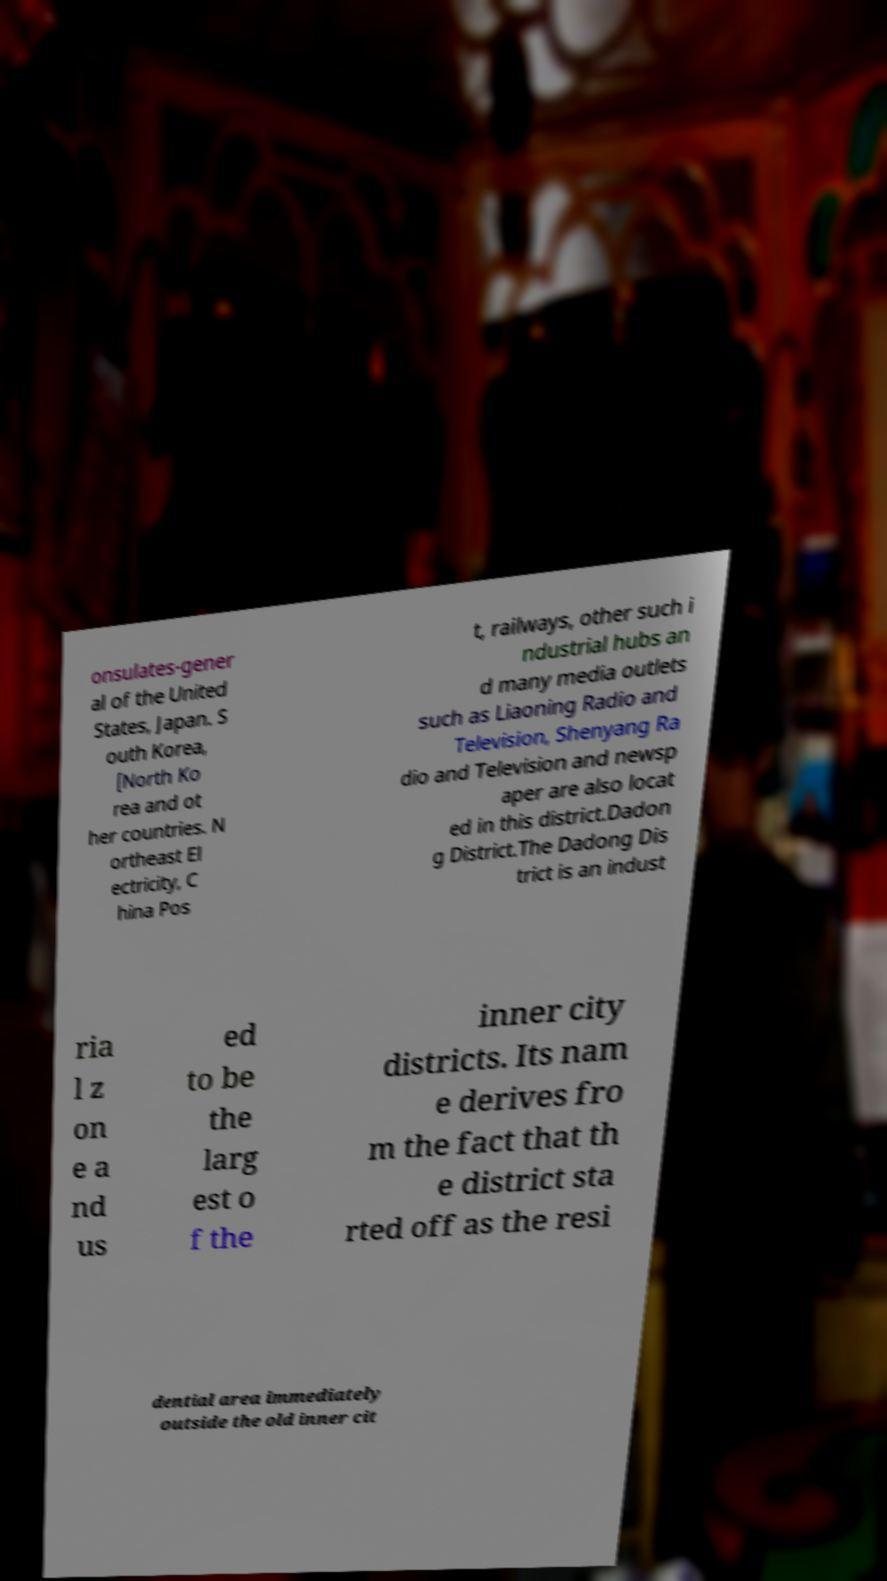Can you read and provide the text displayed in the image?This photo seems to have some interesting text. Can you extract and type it out for me? onsulates-gener al of the United States, Japan. S outh Korea, [North Ko rea and ot her countries. N ortheast El ectricity, C hina Pos t, railways, other such i ndustrial hubs an d many media outlets such as Liaoning Radio and Television, Shenyang Ra dio and Television and newsp aper are also locat ed in this district.Dadon g District.The Dadong Dis trict is an indust ria l z on e a nd us ed to be the larg est o f the inner city districts. Its nam e derives fro m the fact that th e district sta rted off as the resi dential area immediately outside the old inner cit 